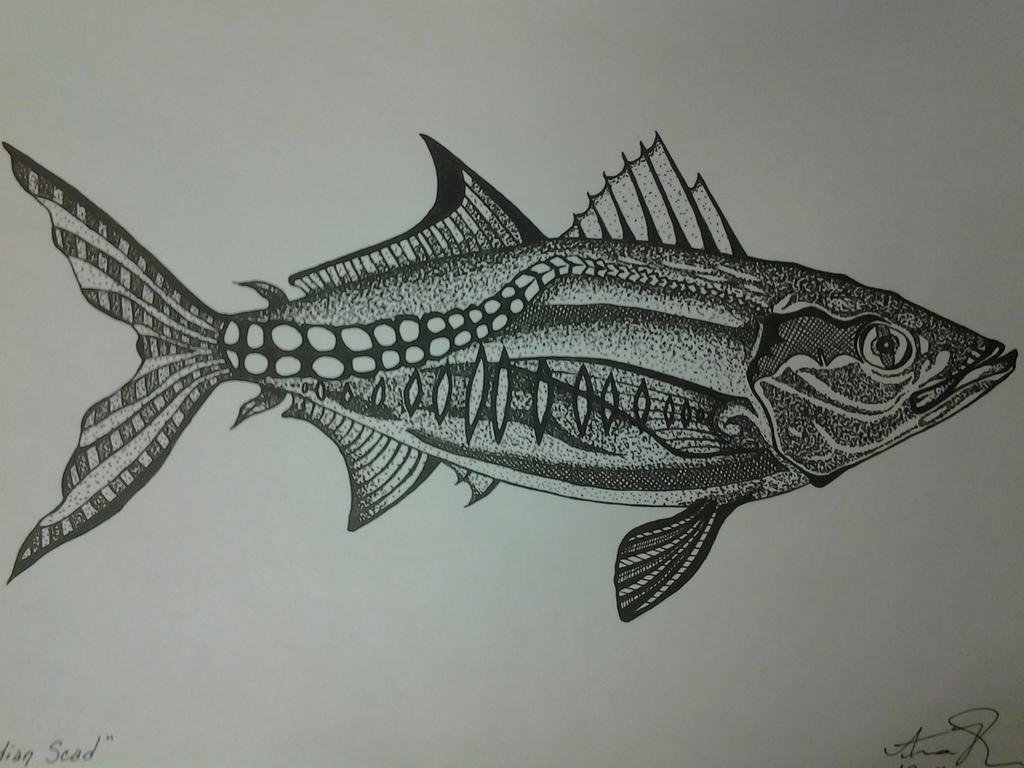What type of drawing is shown in the image? The drawing is a pencil drawing. What is the subject of the drawing? The drawing depicts a fish. What is the background of the drawing made on? The drawing is made on white paper. What type of receipt is visible in the image? There is no receipt present in the image; it is a pencil drawing of a fish on white paper. Can you tell me how many sails are attached to the fish in the drawing? The drawing depicts a fish, not a sail, so there are no sails attached to the fish. 